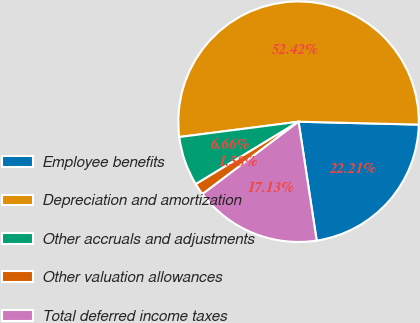Convert chart to OTSL. <chart><loc_0><loc_0><loc_500><loc_500><pie_chart><fcel>Employee benefits<fcel>Depreciation and amortization<fcel>Other accruals and adjustments<fcel>Other valuation allowances<fcel>Total deferred income taxes<nl><fcel>22.21%<fcel>52.41%<fcel>6.66%<fcel>1.58%<fcel>17.13%<nl></chart> 